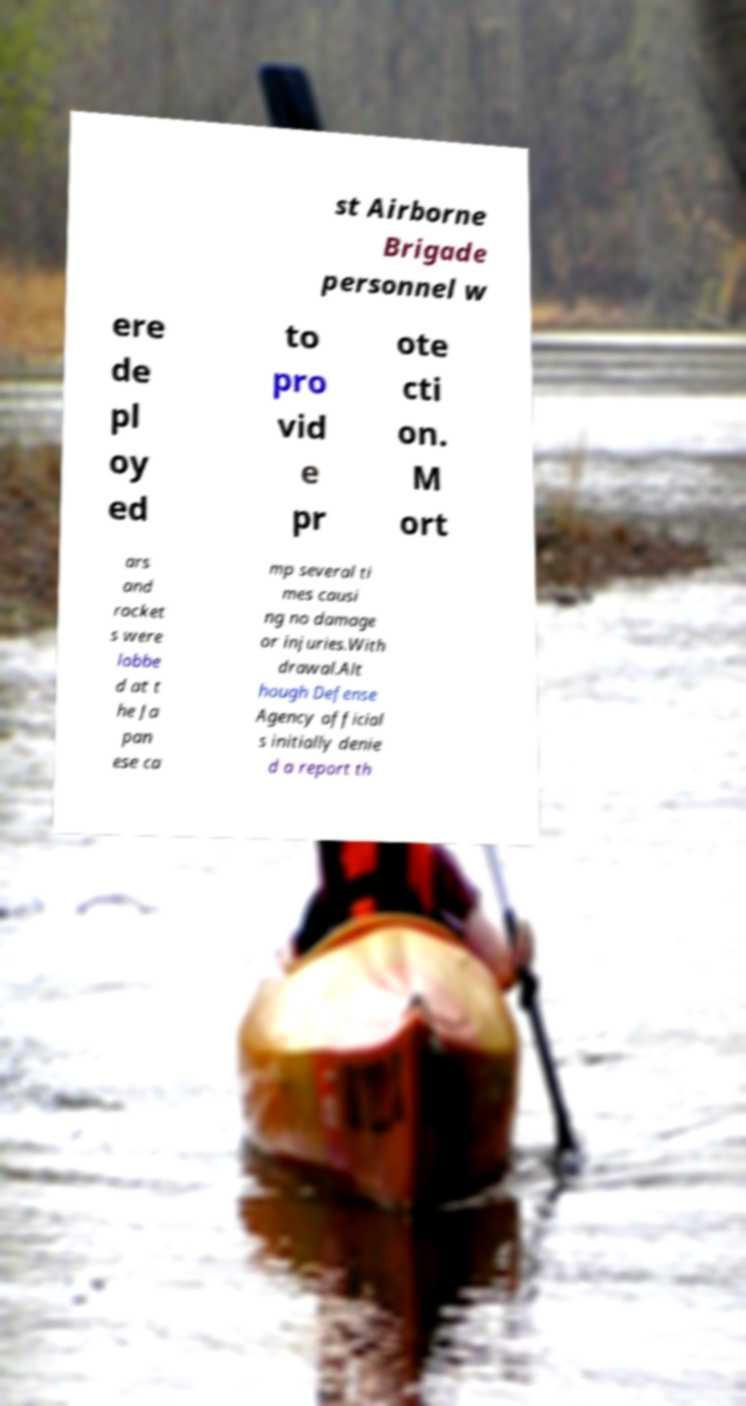Can you read and provide the text displayed in the image?This photo seems to have some interesting text. Can you extract and type it out for me? st Airborne Brigade personnel w ere de pl oy ed to pro vid e pr ote cti on. M ort ars and rocket s were lobbe d at t he Ja pan ese ca mp several ti mes causi ng no damage or injuries.With drawal.Alt hough Defense Agency official s initially denie d a report th 